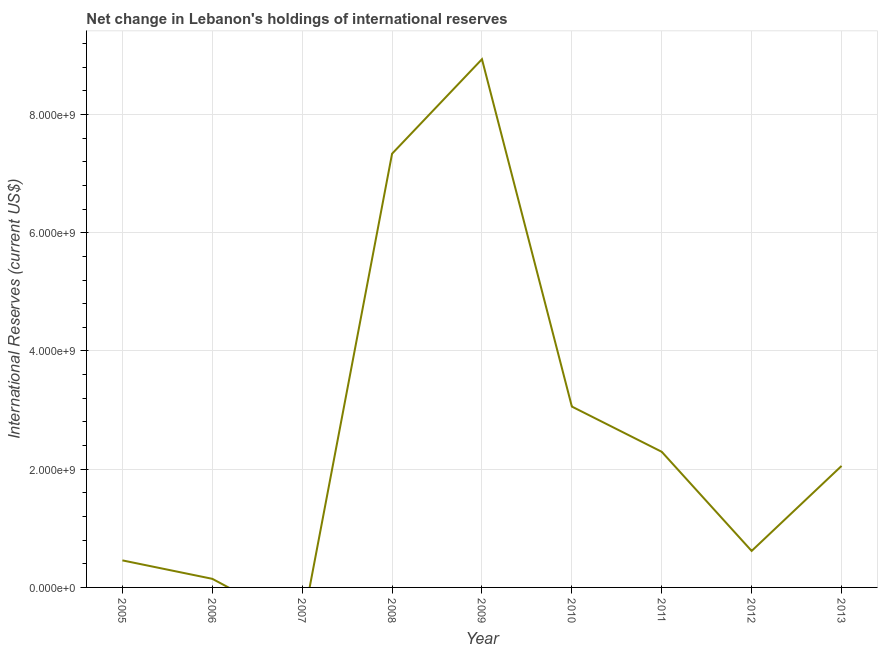What is the reserves and related items in 2006?
Offer a terse response. 1.46e+08. Across all years, what is the maximum reserves and related items?
Your answer should be very brief. 8.94e+09. What is the sum of the reserves and related items?
Provide a short and direct response. 2.49e+1. What is the difference between the reserves and related items in 2005 and 2008?
Offer a very short reply. -6.88e+09. What is the average reserves and related items per year?
Your answer should be compact. 2.77e+09. What is the median reserves and related items?
Offer a very short reply. 2.06e+09. In how many years, is the reserves and related items greater than 2000000000 US$?
Your answer should be compact. 5. What is the ratio of the reserves and related items in 2009 to that in 2011?
Your answer should be very brief. 3.89. Is the reserves and related items in 2012 less than that in 2013?
Your answer should be very brief. Yes. Is the difference between the reserves and related items in 2010 and 2011 greater than the difference between any two years?
Your answer should be very brief. No. What is the difference between the highest and the second highest reserves and related items?
Your answer should be very brief. 1.60e+09. Is the sum of the reserves and related items in 2006 and 2008 greater than the maximum reserves and related items across all years?
Give a very brief answer. No. What is the difference between the highest and the lowest reserves and related items?
Provide a succinct answer. 8.94e+09. What is the difference between two consecutive major ticks on the Y-axis?
Provide a short and direct response. 2.00e+09. Are the values on the major ticks of Y-axis written in scientific E-notation?
Offer a very short reply. Yes. Does the graph contain grids?
Provide a succinct answer. Yes. What is the title of the graph?
Provide a succinct answer. Net change in Lebanon's holdings of international reserves. What is the label or title of the Y-axis?
Keep it short and to the point. International Reserves (current US$). What is the International Reserves (current US$) of 2005?
Provide a succinct answer. 4.58e+08. What is the International Reserves (current US$) of 2006?
Your answer should be very brief. 1.46e+08. What is the International Reserves (current US$) of 2008?
Offer a terse response. 7.34e+09. What is the International Reserves (current US$) of 2009?
Provide a short and direct response. 8.94e+09. What is the International Reserves (current US$) in 2010?
Your answer should be very brief. 3.06e+09. What is the International Reserves (current US$) of 2011?
Your answer should be compact. 2.29e+09. What is the International Reserves (current US$) in 2012?
Provide a short and direct response. 6.17e+08. What is the International Reserves (current US$) in 2013?
Offer a terse response. 2.06e+09. What is the difference between the International Reserves (current US$) in 2005 and 2006?
Keep it short and to the point. 3.12e+08. What is the difference between the International Reserves (current US$) in 2005 and 2008?
Keep it short and to the point. -6.88e+09. What is the difference between the International Reserves (current US$) in 2005 and 2009?
Ensure brevity in your answer.  -8.48e+09. What is the difference between the International Reserves (current US$) in 2005 and 2010?
Your response must be concise. -2.60e+09. What is the difference between the International Reserves (current US$) in 2005 and 2011?
Your answer should be very brief. -1.84e+09. What is the difference between the International Reserves (current US$) in 2005 and 2012?
Make the answer very short. -1.60e+08. What is the difference between the International Reserves (current US$) in 2005 and 2013?
Your response must be concise. -1.60e+09. What is the difference between the International Reserves (current US$) in 2006 and 2008?
Offer a terse response. -7.19e+09. What is the difference between the International Reserves (current US$) in 2006 and 2009?
Offer a terse response. -8.79e+09. What is the difference between the International Reserves (current US$) in 2006 and 2010?
Provide a succinct answer. -2.91e+09. What is the difference between the International Reserves (current US$) in 2006 and 2011?
Ensure brevity in your answer.  -2.15e+09. What is the difference between the International Reserves (current US$) in 2006 and 2012?
Offer a terse response. -4.72e+08. What is the difference between the International Reserves (current US$) in 2006 and 2013?
Offer a very short reply. -1.91e+09. What is the difference between the International Reserves (current US$) in 2008 and 2009?
Give a very brief answer. -1.60e+09. What is the difference between the International Reserves (current US$) in 2008 and 2010?
Provide a short and direct response. 4.28e+09. What is the difference between the International Reserves (current US$) in 2008 and 2011?
Offer a very short reply. 5.04e+09. What is the difference between the International Reserves (current US$) in 2008 and 2012?
Give a very brief answer. 6.72e+09. What is the difference between the International Reserves (current US$) in 2008 and 2013?
Provide a short and direct response. 5.28e+09. What is the difference between the International Reserves (current US$) in 2009 and 2010?
Your answer should be very brief. 5.88e+09. What is the difference between the International Reserves (current US$) in 2009 and 2011?
Offer a very short reply. 6.64e+09. What is the difference between the International Reserves (current US$) in 2009 and 2012?
Offer a very short reply. 8.32e+09. What is the difference between the International Reserves (current US$) in 2009 and 2013?
Keep it short and to the point. 6.88e+09. What is the difference between the International Reserves (current US$) in 2010 and 2011?
Keep it short and to the point. 7.65e+08. What is the difference between the International Reserves (current US$) in 2010 and 2012?
Provide a short and direct response. 2.44e+09. What is the difference between the International Reserves (current US$) in 2010 and 2013?
Offer a terse response. 1.00e+09. What is the difference between the International Reserves (current US$) in 2011 and 2012?
Keep it short and to the point. 1.68e+09. What is the difference between the International Reserves (current US$) in 2011 and 2013?
Make the answer very short. 2.39e+08. What is the difference between the International Reserves (current US$) in 2012 and 2013?
Provide a succinct answer. -1.44e+09. What is the ratio of the International Reserves (current US$) in 2005 to that in 2006?
Your response must be concise. 3.14. What is the ratio of the International Reserves (current US$) in 2005 to that in 2008?
Offer a terse response. 0.06. What is the ratio of the International Reserves (current US$) in 2005 to that in 2009?
Provide a succinct answer. 0.05. What is the ratio of the International Reserves (current US$) in 2005 to that in 2011?
Provide a short and direct response. 0.2. What is the ratio of the International Reserves (current US$) in 2005 to that in 2012?
Your answer should be very brief. 0.74. What is the ratio of the International Reserves (current US$) in 2005 to that in 2013?
Offer a very short reply. 0.22. What is the ratio of the International Reserves (current US$) in 2006 to that in 2009?
Provide a succinct answer. 0.02. What is the ratio of the International Reserves (current US$) in 2006 to that in 2010?
Your response must be concise. 0.05. What is the ratio of the International Reserves (current US$) in 2006 to that in 2011?
Your answer should be compact. 0.06. What is the ratio of the International Reserves (current US$) in 2006 to that in 2012?
Your response must be concise. 0.24. What is the ratio of the International Reserves (current US$) in 2006 to that in 2013?
Offer a terse response. 0.07. What is the ratio of the International Reserves (current US$) in 2008 to that in 2009?
Make the answer very short. 0.82. What is the ratio of the International Reserves (current US$) in 2008 to that in 2010?
Your response must be concise. 2.4. What is the ratio of the International Reserves (current US$) in 2008 to that in 2011?
Give a very brief answer. 3.2. What is the ratio of the International Reserves (current US$) in 2008 to that in 2012?
Make the answer very short. 11.88. What is the ratio of the International Reserves (current US$) in 2008 to that in 2013?
Ensure brevity in your answer.  3.57. What is the ratio of the International Reserves (current US$) in 2009 to that in 2010?
Ensure brevity in your answer.  2.92. What is the ratio of the International Reserves (current US$) in 2009 to that in 2011?
Your answer should be very brief. 3.9. What is the ratio of the International Reserves (current US$) in 2009 to that in 2012?
Keep it short and to the point. 14.47. What is the ratio of the International Reserves (current US$) in 2009 to that in 2013?
Ensure brevity in your answer.  4.35. What is the ratio of the International Reserves (current US$) in 2010 to that in 2011?
Your response must be concise. 1.33. What is the ratio of the International Reserves (current US$) in 2010 to that in 2012?
Provide a succinct answer. 4.96. What is the ratio of the International Reserves (current US$) in 2010 to that in 2013?
Your answer should be compact. 1.49. What is the ratio of the International Reserves (current US$) in 2011 to that in 2012?
Give a very brief answer. 3.72. What is the ratio of the International Reserves (current US$) in 2011 to that in 2013?
Ensure brevity in your answer.  1.12. 